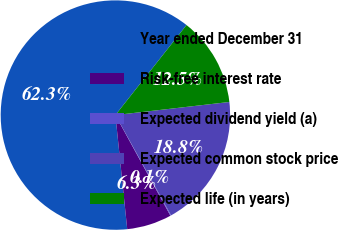<chart> <loc_0><loc_0><loc_500><loc_500><pie_chart><fcel>Year ended December 31<fcel>Risk-free interest rate<fcel>Expected dividend yield (a)<fcel>Expected common stock price<fcel>Expected life (in years)<nl><fcel>62.29%<fcel>6.32%<fcel>0.1%<fcel>18.76%<fcel>12.54%<nl></chart> 